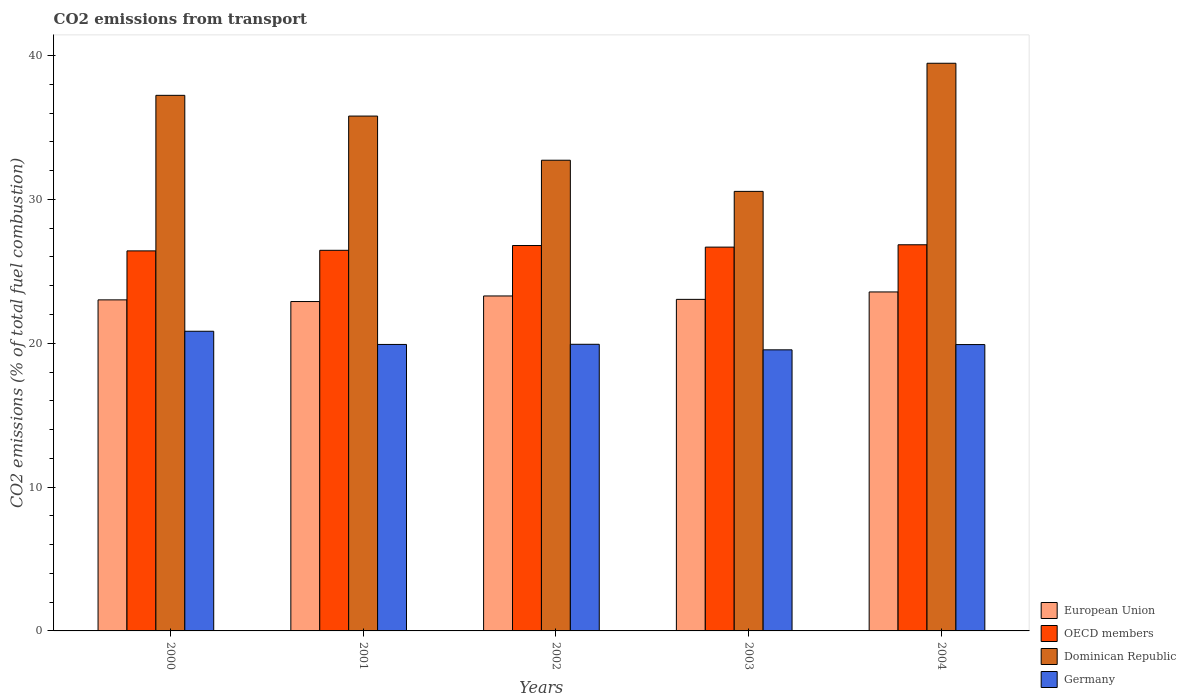How many different coloured bars are there?
Provide a succinct answer. 4. Are the number of bars on each tick of the X-axis equal?
Give a very brief answer. Yes. How many bars are there on the 1st tick from the left?
Your answer should be compact. 4. How many bars are there on the 4th tick from the right?
Keep it short and to the point. 4. What is the label of the 4th group of bars from the left?
Provide a short and direct response. 2003. In how many cases, is the number of bars for a given year not equal to the number of legend labels?
Give a very brief answer. 0. What is the total CO2 emitted in Germany in 2002?
Your answer should be very brief. 19.93. Across all years, what is the maximum total CO2 emitted in European Union?
Offer a very short reply. 23.57. Across all years, what is the minimum total CO2 emitted in European Union?
Keep it short and to the point. 22.9. What is the total total CO2 emitted in Germany in the graph?
Give a very brief answer. 100.13. What is the difference between the total CO2 emitted in Dominican Republic in 2002 and that in 2003?
Offer a terse response. 2.17. What is the difference between the total CO2 emitted in Dominican Republic in 2000 and the total CO2 emitted in OECD members in 2004?
Your answer should be very brief. 10.39. What is the average total CO2 emitted in OECD members per year?
Offer a very short reply. 26.64. In the year 2000, what is the difference between the total CO2 emitted in European Union and total CO2 emitted in OECD members?
Offer a terse response. -3.41. What is the ratio of the total CO2 emitted in Germany in 2003 to that in 2004?
Your answer should be compact. 0.98. Is the total CO2 emitted in European Union in 2001 less than that in 2003?
Make the answer very short. Yes. What is the difference between the highest and the second highest total CO2 emitted in Dominican Republic?
Provide a succinct answer. 2.23. What is the difference between the highest and the lowest total CO2 emitted in Dominican Republic?
Offer a very short reply. 8.91. In how many years, is the total CO2 emitted in Dominican Republic greater than the average total CO2 emitted in Dominican Republic taken over all years?
Offer a terse response. 3. Is it the case that in every year, the sum of the total CO2 emitted in Germany and total CO2 emitted in European Union is greater than the sum of total CO2 emitted in Dominican Republic and total CO2 emitted in OECD members?
Your answer should be compact. No. What does the 2nd bar from the left in 2003 represents?
Your answer should be compact. OECD members. Is it the case that in every year, the sum of the total CO2 emitted in European Union and total CO2 emitted in Germany is greater than the total CO2 emitted in OECD members?
Offer a very short reply. Yes. How many bars are there?
Give a very brief answer. 20. How many years are there in the graph?
Your answer should be very brief. 5. Are the values on the major ticks of Y-axis written in scientific E-notation?
Your answer should be very brief. No. Does the graph contain grids?
Offer a terse response. No. Where does the legend appear in the graph?
Offer a terse response. Bottom right. What is the title of the graph?
Give a very brief answer. CO2 emissions from transport. What is the label or title of the Y-axis?
Ensure brevity in your answer.  CO2 emissions (% of total fuel combustion). What is the CO2 emissions (% of total fuel combustion) of European Union in 2000?
Ensure brevity in your answer.  23.02. What is the CO2 emissions (% of total fuel combustion) in OECD members in 2000?
Give a very brief answer. 26.42. What is the CO2 emissions (% of total fuel combustion) of Dominican Republic in 2000?
Provide a succinct answer. 37.24. What is the CO2 emissions (% of total fuel combustion) of Germany in 2000?
Provide a succinct answer. 20.83. What is the CO2 emissions (% of total fuel combustion) of European Union in 2001?
Provide a short and direct response. 22.9. What is the CO2 emissions (% of total fuel combustion) of OECD members in 2001?
Provide a short and direct response. 26.46. What is the CO2 emissions (% of total fuel combustion) of Dominican Republic in 2001?
Your response must be concise. 35.8. What is the CO2 emissions (% of total fuel combustion) of Germany in 2001?
Provide a short and direct response. 19.92. What is the CO2 emissions (% of total fuel combustion) in European Union in 2002?
Offer a very short reply. 23.29. What is the CO2 emissions (% of total fuel combustion) in OECD members in 2002?
Offer a terse response. 26.79. What is the CO2 emissions (% of total fuel combustion) in Dominican Republic in 2002?
Offer a very short reply. 32.73. What is the CO2 emissions (% of total fuel combustion) in Germany in 2002?
Your answer should be very brief. 19.93. What is the CO2 emissions (% of total fuel combustion) of European Union in 2003?
Offer a terse response. 23.05. What is the CO2 emissions (% of total fuel combustion) of OECD members in 2003?
Your answer should be compact. 26.68. What is the CO2 emissions (% of total fuel combustion) of Dominican Republic in 2003?
Offer a terse response. 30.56. What is the CO2 emissions (% of total fuel combustion) in Germany in 2003?
Your response must be concise. 19.54. What is the CO2 emissions (% of total fuel combustion) of European Union in 2004?
Give a very brief answer. 23.57. What is the CO2 emissions (% of total fuel combustion) in OECD members in 2004?
Provide a short and direct response. 26.85. What is the CO2 emissions (% of total fuel combustion) of Dominican Republic in 2004?
Your answer should be compact. 39.47. What is the CO2 emissions (% of total fuel combustion) in Germany in 2004?
Ensure brevity in your answer.  19.91. Across all years, what is the maximum CO2 emissions (% of total fuel combustion) of European Union?
Your answer should be very brief. 23.57. Across all years, what is the maximum CO2 emissions (% of total fuel combustion) of OECD members?
Offer a very short reply. 26.85. Across all years, what is the maximum CO2 emissions (% of total fuel combustion) of Dominican Republic?
Your answer should be compact. 39.47. Across all years, what is the maximum CO2 emissions (% of total fuel combustion) of Germany?
Offer a very short reply. 20.83. Across all years, what is the minimum CO2 emissions (% of total fuel combustion) in European Union?
Give a very brief answer. 22.9. Across all years, what is the minimum CO2 emissions (% of total fuel combustion) of OECD members?
Offer a very short reply. 26.42. Across all years, what is the minimum CO2 emissions (% of total fuel combustion) of Dominican Republic?
Provide a succinct answer. 30.56. Across all years, what is the minimum CO2 emissions (% of total fuel combustion) in Germany?
Your response must be concise. 19.54. What is the total CO2 emissions (% of total fuel combustion) of European Union in the graph?
Ensure brevity in your answer.  115.82. What is the total CO2 emissions (% of total fuel combustion) of OECD members in the graph?
Offer a very short reply. 133.21. What is the total CO2 emissions (% of total fuel combustion) in Dominican Republic in the graph?
Make the answer very short. 175.78. What is the total CO2 emissions (% of total fuel combustion) in Germany in the graph?
Offer a very short reply. 100.13. What is the difference between the CO2 emissions (% of total fuel combustion) of European Union in 2000 and that in 2001?
Provide a succinct answer. 0.12. What is the difference between the CO2 emissions (% of total fuel combustion) of OECD members in 2000 and that in 2001?
Ensure brevity in your answer.  -0.04. What is the difference between the CO2 emissions (% of total fuel combustion) of Dominican Republic in 2000 and that in 2001?
Your answer should be compact. 1.44. What is the difference between the CO2 emissions (% of total fuel combustion) in Germany in 2000 and that in 2001?
Offer a very short reply. 0.92. What is the difference between the CO2 emissions (% of total fuel combustion) in European Union in 2000 and that in 2002?
Offer a terse response. -0.27. What is the difference between the CO2 emissions (% of total fuel combustion) in OECD members in 2000 and that in 2002?
Provide a short and direct response. -0.37. What is the difference between the CO2 emissions (% of total fuel combustion) of Dominican Republic in 2000 and that in 2002?
Make the answer very short. 4.51. What is the difference between the CO2 emissions (% of total fuel combustion) in Germany in 2000 and that in 2002?
Offer a terse response. 0.91. What is the difference between the CO2 emissions (% of total fuel combustion) in European Union in 2000 and that in 2003?
Provide a succinct answer. -0.04. What is the difference between the CO2 emissions (% of total fuel combustion) in OECD members in 2000 and that in 2003?
Offer a very short reply. -0.26. What is the difference between the CO2 emissions (% of total fuel combustion) of Dominican Republic in 2000 and that in 2003?
Ensure brevity in your answer.  6.68. What is the difference between the CO2 emissions (% of total fuel combustion) of Germany in 2000 and that in 2003?
Ensure brevity in your answer.  1.29. What is the difference between the CO2 emissions (% of total fuel combustion) of European Union in 2000 and that in 2004?
Ensure brevity in your answer.  -0.55. What is the difference between the CO2 emissions (% of total fuel combustion) of OECD members in 2000 and that in 2004?
Offer a terse response. -0.43. What is the difference between the CO2 emissions (% of total fuel combustion) of Dominican Republic in 2000 and that in 2004?
Your response must be concise. -2.23. What is the difference between the CO2 emissions (% of total fuel combustion) of Germany in 2000 and that in 2004?
Make the answer very short. 0.93. What is the difference between the CO2 emissions (% of total fuel combustion) of European Union in 2001 and that in 2002?
Make the answer very short. -0.39. What is the difference between the CO2 emissions (% of total fuel combustion) of OECD members in 2001 and that in 2002?
Offer a very short reply. -0.33. What is the difference between the CO2 emissions (% of total fuel combustion) of Dominican Republic in 2001 and that in 2002?
Give a very brief answer. 3.07. What is the difference between the CO2 emissions (% of total fuel combustion) of Germany in 2001 and that in 2002?
Provide a succinct answer. -0.01. What is the difference between the CO2 emissions (% of total fuel combustion) of European Union in 2001 and that in 2003?
Give a very brief answer. -0.15. What is the difference between the CO2 emissions (% of total fuel combustion) in OECD members in 2001 and that in 2003?
Offer a very short reply. -0.22. What is the difference between the CO2 emissions (% of total fuel combustion) in Dominican Republic in 2001 and that in 2003?
Provide a short and direct response. 5.24. What is the difference between the CO2 emissions (% of total fuel combustion) in Germany in 2001 and that in 2003?
Provide a short and direct response. 0.37. What is the difference between the CO2 emissions (% of total fuel combustion) of European Union in 2001 and that in 2004?
Keep it short and to the point. -0.67. What is the difference between the CO2 emissions (% of total fuel combustion) in OECD members in 2001 and that in 2004?
Provide a succinct answer. -0.39. What is the difference between the CO2 emissions (% of total fuel combustion) of Dominican Republic in 2001 and that in 2004?
Your answer should be very brief. -3.67. What is the difference between the CO2 emissions (% of total fuel combustion) in Germany in 2001 and that in 2004?
Offer a terse response. 0.01. What is the difference between the CO2 emissions (% of total fuel combustion) in European Union in 2002 and that in 2003?
Offer a terse response. 0.24. What is the difference between the CO2 emissions (% of total fuel combustion) in OECD members in 2002 and that in 2003?
Offer a terse response. 0.11. What is the difference between the CO2 emissions (% of total fuel combustion) of Dominican Republic in 2002 and that in 2003?
Offer a terse response. 2.17. What is the difference between the CO2 emissions (% of total fuel combustion) in Germany in 2002 and that in 2003?
Offer a very short reply. 0.39. What is the difference between the CO2 emissions (% of total fuel combustion) of European Union in 2002 and that in 2004?
Provide a short and direct response. -0.28. What is the difference between the CO2 emissions (% of total fuel combustion) in OECD members in 2002 and that in 2004?
Provide a short and direct response. -0.05. What is the difference between the CO2 emissions (% of total fuel combustion) in Dominican Republic in 2002 and that in 2004?
Provide a short and direct response. -6.74. What is the difference between the CO2 emissions (% of total fuel combustion) of Germany in 2002 and that in 2004?
Your answer should be very brief. 0.02. What is the difference between the CO2 emissions (% of total fuel combustion) of European Union in 2003 and that in 2004?
Your answer should be compact. -0.52. What is the difference between the CO2 emissions (% of total fuel combustion) of OECD members in 2003 and that in 2004?
Ensure brevity in your answer.  -0.16. What is the difference between the CO2 emissions (% of total fuel combustion) of Dominican Republic in 2003 and that in 2004?
Offer a terse response. -8.91. What is the difference between the CO2 emissions (% of total fuel combustion) of Germany in 2003 and that in 2004?
Your answer should be compact. -0.37. What is the difference between the CO2 emissions (% of total fuel combustion) in European Union in 2000 and the CO2 emissions (% of total fuel combustion) in OECD members in 2001?
Provide a short and direct response. -3.45. What is the difference between the CO2 emissions (% of total fuel combustion) of European Union in 2000 and the CO2 emissions (% of total fuel combustion) of Dominican Republic in 2001?
Give a very brief answer. -12.78. What is the difference between the CO2 emissions (% of total fuel combustion) in European Union in 2000 and the CO2 emissions (% of total fuel combustion) in Germany in 2001?
Keep it short and to the point. 3.1. What is the difference between the CO2 emissions (% of total fuel combustion) in OECD members in 2000 and the CO2 emissions (% of total fuel combustion) in Dominican Republic in 2001?
Offer a terse response. -9.37. What is the difference between the CO2 emissions (% of total fuel combustion) of OECD members in 2000 and the CO2 emissions (% of total fuel combustion) of Germany in 2001?
Give a very brief answer. 6.5. What is the difference between the CO2 emissions (% of total fuel combustion) of Dominican Republic in 2000 and the CO2 emissions (% of total fuel combustion) of Germany in 2001?
Your response must be concise. 17.32. What is the difference between the CO2 emissions (% of total fuel combustion) of European Union in 2000 and the CO2 emissions (% of total fuel combustion) of OECD members in 2002?
Make the answer very short. -3.78. What is the difference between the CO2 emissions (% of total fuel combustion) of European Union in 2000 and the CO2 emissions (% of total fuel combustion) of Dominican Republic in 2002?
Provide a succinct answer. -9.71. What is the difference between the CO2 emissions (% of total fuel combustion) of European Union in 2000 and the CO2 emissions (% of total fuel combustion) of Germany in 2002?
Make the answer very short. 3.09. What is the difference between the CO2 emissions (% of total fuel combustion) of OECD members in 2000 and the CO2 emissions (% of total fuel combustion) of Dominican Republic in 2002?
Offer a very short reply. -6.3. What is the difference between the CO2 emissions (% of total fuel combustion) of OECD members in 2000 and the CO2 emissions (% of total fuel combustion) of Germany in 2002?
Provide a short and direct response. 6.49. What is the difference between the CO2 emissions (% of total fuel combustion) in Dominican Republic in 2000 and the CO2 emissions (% of total fuel combustion) in Germany in 2002?
Offer a terse response. 17.31. What is the difference between the CO2 emissions (% of total fuel combustion) of European Union in 2000 and the CO2 emissions (% of total fuel combustion) of OECD members in 2003?
Provide a succinct answer. -3.67. What is the difference between the CO2 emissions (% of total fuel combustion) of European Union in 2000 and the CO2 emissions (% of total fuel combustion) of Dominican Republic in 2003?
Offer a terse response. -7.54. What is the difference between the CO2 emissions (% of total fuel combustion) of European Union in 2000 and the CO2 emissions (% of total fuel combustion) of Germany in 2003?
Offer a very short reply. 3.47. What is the difference between the CO2 emissions (% of total fuel combustion) in OECD members in 2000 and the CO2 emissions (% of total fuel combustion) in Dominican Republic in 2003?
Keep it short and to the point. -4.14. What is the difference between the CO2 emissions (% of total fuel combustion) in OECD members in 2000 and the CO2 emissions (% of total fuel combustion) in Germany in 2003?
Provide a short and direct response. 6.88. What is the difference between the CO2 emissions (% of total fuel combustion) in Dominican Republic in 2000 and the CO2 emissions (% of total fuel combustion) in Germany in 2003?
Ensure brevity in your answer.  17.69. What is the difference between the CO2 emissions (% of total fuel combustion) of European Union in 2000 and the CO2 emissions (% of total fuel combustion) of OECD members in 2004?
Make the answer very short. -3.83. What is the difference between the CO2 emissions (% of total fuel combustion) in European Union in 2000 and the CO2 emissions (% of total fuel combustion) in Dominican Republic in 2004?
Ensure brevity in your answer.  -16.45. What is the difference between the CO2 emissions (% of total fuel combustion) in European Union in 2000 and the CO2 emissions (% of total fuel combustion) in Germany in 2004?
Offer a very short reply. 3.11. What is the difference between the CO2 emissions (% of total fuel combustion) of OECD members in 2000 and the CO2 emissions (% of total fuel combustion) of Dominican Republic in 2004?
Ensure brevity in your answer.  -13.04. What is the difference between the CO2 emissions (% of total fuel combustion) of OECD members in 2000 and the CO2 emissions (% of total fuel combustion) of Germany in 2004?
Offer a very short reply. 6.51. What is the difference between the CO2 emissions (% of total fuel combustion) of Dominican Republic in 2000 and the CO2 emissions (% of total fuel combustion) of Germany in 2004?
Offer a terse response. 17.33. What is the difference between the CO2 emissions (% of total fuel combustion) in European Union in 2001 and the CO2 emissions (% of total fuel combustion) in OECD members in 2002?
Ensure brevity in your answer.  -3.89. What is the difference between the CO2 emissions (% of total fuel combustion) in European Union in 2001 and the CO2 emissions (% of total fuel combustion) in Dominican Republic in 2002?
Keep it short and to the point. -9.82. What is the difference between the CO2 emissions (% of total fuel combustion) in European Union in 2001 and the CO2 emissions (% of total fuel combustion) in Germany in 2002?
Ensure brevity in your answer.  2.97. What is the difference between the CO2 emissions (% of total fuel combustion) in OECD members in 2001 and the CO2 emissions (% of total fuel combustion) in Dominican Republic in 2002?
Ensure brevity in your answer.  -6.26. What is the difference between the CO2 emissions (% of total fuel combustion) in OECD members in 2001 and the CO2 emissions (% of total fuel combustion) in Germany in 2002?
Your answer should be very brief. 6.53. What is the difference between the CO2 emissions (% of total fuel combustion) of Dominican Republic in 2001 and the CO2 emissions (% of total fuel combustion) of Germany in 2002?
Give a very brief answer. 15.87. What is the difference between the CO2 emissions (% of total fuel combustion) of European Union in 2001 and the CO2 emissions (% of total fuel combustion) of OECD members in 2003?
Provide a short and direct response. -3.78. What is the difference between the CO2 emissions (% of total fuel combustion) of European Union in 2001 and the CO2 emissions (% of total fuel combustion) of Dominican Republic in 2003?
Your answer should be compact. -7.66. What is the difference between the CO2 emissions (% of total fuel combustion) of European Union in 2001 and the CO2 emissions (% of total fuel combustion) of Germany in 2003?
Make the answer very short. 3.36. What is the difference between the CO2 emissions (% of total fuel combustion) of OECD members in 2001 and the CO2 emissions (% of total fuel combustion) of Dominican Republic in 2003?
Offer a very short reply. -4.1. What is the difference between the CO2 emissions (% of total fuel combustion) in OECD members in 2001 and the CO2 emissions (% of total fuel combustion) in Germany in 2003?
Make the answer very short. 6.92. What is the difference between the CO2 emissions (% of total fuel combustion) in Dominican Republic in 2001 and the CO2 emissions (% of total fuel combustion) in Germany in 2003?
Your answer should be very brief. 16.25. What is the difference between the CO2 emissions (% of total fuel combustion) in European Union in 2001 and the CO2 emissions (% of total fuel combustion) in OECD members in 2004?
Offer a very short reply. -3.95. What is the difference between the CO2 emissions (% of total fuel combustion) in European Union in 2001 and the CO2 emissions (% of total fuel combustion) in Dominican Republic in 2004?
Offer a very short reply. -16.57. What is the difference between the CO2 emissions (% of total fuel combustion) of European Union in 2001 and the CO2 emissions (% of total fuel combustion) of Germany in 2004?
Your response must be concise. 2.99. What is the difference between the CO2 emissions (% of total fuel combustion) of OECD members in 2001 and the CO2 emissions (% of total fuel combustion) of Dominican Republic in 2004?
Offer a terse response. -13. What is the difference between the CO2 emissions (% of total fuel combustion) of OECD members in 2001 and the CO2 emissions (% of total fuel combustion) of Germany in 2004?
Ensure brevity in your answer.  6.55. What is the difference between the CO2 emissions (% of total fuel combustion) in Dominican Republic in 2001 and the CO2 emissions (% of total fuel combustion) in Germany in 2004?
Offer a terse response. 15.89. What is the difference between the CO2 emissions (% of total fuel combustion) of European Union in 2002 and the CO2 emissions (% of total fuel combustion) of OECD members in 2003?
Make the answer very short. -3.4. What is the difference between the CO2 emissions (% of total fuel combustion) in European Union in 2002 and the CO2 emissions (% of total fuel combustion) in Dominican Republic in 2003?
Your answer should be compact. -7.27. What is the difference between the CO2 emissions (% of total fuel combustion) in European Union in 2002 and the CO2 emissions (% of total fuel combustion) in Germany in 2003?
Your answer should be compact. 3.75. What is the difference between the CO2 emissions (% of total fuel combustion) of OECD members in 2002 and the CO2 emissions (% of total fuel combustion) of Dominican Republic in 2003?
Your response must be concise. -3.76. What is the difference between the CO2 emissions (% of total fuel combustion) in OECD members in 2002 and the CO2 emissions (% of total fuel combustion) in Germany in 2003?
Your answer should be very brief. 7.25. What is the difference between the CO2 emissions (% of total fuel combustion) in Dominican Republic in 2002 and the CO2 emissions (% of total fuel combustion) in Germany in 2003?
Your answer should be very brief. 13.18. What is the difference between the CO2 emissions (% of total fuel combustion) in European Union in 2002 and the CO2 emissions (% of total fuel combustion) in OECD members in 2004?
Your answer should be very brief. -3.56. What is the difference between the CO2 emissions (% of total fuel combustion) in European Union in 2002 and the CO2 emissions (% of total fuel combustion) in Dominican Republic in 2004?
Offer a very short reply. -16.18. What is the difference between the CO2 emissions (% of total fuel combustion) in European Union in 2002 and the CO2 emissions (% of total fuel combustion) in Germany in 2004?
Your answer should be very brief. 3.38. What is the difference between the CO2 emissions (% of total fuel combustion) of OECD members in 2002 and the CO2 emissions (% of total fuel combustion) of Dominican Republic in 2004?
Your response must be concise. -12.67. What is the difference between the CO2 emissions (% of total fuel combustion) in OECD members in 2002 and the CO2 emissions (% of total fuel combustion) in Germany in 2004?
Your answer should be compact. 6.89. What is the difference between the CO2 emissions (% of total fuel combustion) of Dominican Republic in 2002 and the CO2 emissions (% of total fuel combustion) of Germany in 2004?
Provide a succinct answer. 12.82. What is the difference between the CO2 emissions (% of total fuel combustion) in European Union in 2003 and the CO2 emissions (% of total fuel combustion) in OECD members in 2004?
Offer a very short reply. -3.8. What is the difference between the CO2 emissions (% of total fuel combustion) of European Union in 2003 and the CO2 emissions (% of total fuel combustion) of Dominican Republic in 2004?
Offer a terse response. -16.42. What is the difference between the CO2 emissions (% of total fuel combustion) of European Union in 2003 and the CO2 emissions (% of total fuel combustion) of Germany in 2004?
Keep it short and to the point. 3.14. What is the difference between the CO2 emissions (% of total fuel combustion) in OECD members in 2003 and the CO2 emissions (% of total fuel combustion) in Dominican Republic in 2004?
Give a very brief answer. -12.78. What is the difference between the CO2 emissions (% of total fuel combustion) of OECD members in 2003 and the CO2 emissions (% of total fuel combustion) of Germany in 2004?
Offer a terse response. 6.78. What is the difference between the CO2 emissions (% of total fuel combustion) of Dominican Republic in 2003 and the CO2 emissions (% of total fuel combustion) of Germany in 2004?
Make the answer very short. 10.65. What is the average CO2 emissions (% of total fuel combustion) in European Union per year?
Provide a succinct answer. 23.16. What is the average CO2 emissions (% of total fuel combustion) in OECD members per year?
Give a very brief answer. 26.64. What is the average CO2 emissions (% of total fuel combustion) of Dominican Republic per year?
Provide a succinct answer. 35.16. What is the average CO2 emissions (% of total fuel combustion) in Germany per year?
Your answer should be very brief. 20.03. In the year 2000, what is the difference between the CO2 emissions (% of total fuel combustion) in European Union and CO2 emissions (% of total fuel combustion) in OECD members?
Ensure brevity in your answer.  -3.41. In the year 2000, what is the difference between the CO2 emissions (% of total fuel combustion) of European Union and CO2 emissions (% of total fuel combustion) of Dominican Republic?
Your answer should be compact. -14.22. In the year 2000, what is the difference between the CO2 emissions (% of total fuel combustion) of European Union and CO2 emissions (% of total fuel combustion) of Germany?
Your answer should be compact. 2.18. In the year 2000, what is the difference between the CO2 emissions (% of total fuel combustion) in OECD members and CO2 emissions (% of total fuel combustion) in Dominican Republic?
Provide a short and direct response. -10.81. In the year 2000, what is the difference between the CO2 emissions (% of total fuel combustion) of OECD members and CO2 emissions (% of total fuel combustion) of Germany?
Provide a short and direct response. 5.59. In the year 2000, what is the difference between the CO2 emissions (% of total fuel combustion) in Dominican Republic and CO2 emissions (% of total fuel combustion) in Germany?
Your answer should be compact. 16.4. In the year 2001, what is the difference between the CO2 emissions (% of total fuel combustion) of European Union and CO2 emissions (% of total fuel combustion) of OECD members?
Offer a terse response. -3.56. In the year 2001, what is the difference between the CO2 emissions (% of total fuel combustion) in European Union and CO2 emissions (% of total fuel combustion) in Dominican Republic?
Give a very brief answer. -12.9. In the year 2001, what is the difference between the CO2 emissions (% of total fuel combustion) in European Union and CO2 emissions (% of total fuel combustion) in Germany?
Your answer should be compact. 2.98. In the year 2001, what is the difference between the CO2 emissions (% of total fuel combustion) of OECD members and CO2 emissions (% of total fuel combustion) of Dominican Republic?
Provide a short and direct response. -9.33. In the year 2001, what is the difference between the CO2 emissions (% of total fuel combustion) in OECD members and CO2 emissions (% of total fuel combustion) in Germany?
Offer a terse response. 6.54. In the year 2001, what is the difference between the CO2 emissions (% of total fuel combustion) in Dominican Republic and CO2 emissions (% of total fuel combustion) in Germany?
Give a very brief answer. 15.88. In the year 2002, what is the difference between the CO2 emissions (% of total fuel combustion) of European Union and CO2 emissions (% of total fuel combustion) of OECD members?
Offer a terse response. -3.51. In the year 2002, what is the difference between the CO2 emissions (% of total fuel combustion) of European Union and CO2 emissions (% of total fuel combustion) of Dominican Republic?
Offer a terse response. -9.44. In the year 2002, what is the difference between the CO2 emissions (% of total fuel combustion) of European Union and CO2 emissions (% of total fuel combustion) of Germany?
Offer a terse response. 3.36. In the year 2002, what is the difference between the CO2 emissions (% of total fuel combustion) in OECD members and CO2 emissions (% of total fuel combustion) in Dominican Republic?
Ensure brevity in your answer.  -5.93. In the year 2002, what is the difference between the CO2 emissions (% of total fuel combustion) of OECD members and CO2 emissions (% of total fuel combustion) of Germany?
Your answer should be compact. 6.87. In the year 2002, what is the difference between the CO2 emissions (% of total fuel combustion) in Dominican Republic and CO2 emissions (% of total fuel combustion) in Germany?
Provide a succinct answer. 12.8. In the year 2003, what is the difference between the CO2 emissions (% of total fuel combustion) in European Union and CO2 emissions (% of total fuel combustion) in OECD members?
Offer a terse response. -3.63. In the year 2003, what is the difference between the CO2 emissions (% of total fuel combustion) in European Union and CO2 emissions (% of total fuel combustion) in Dominican Republic?
Your answer should be compact. -7.51. In the year 2003, what is the difference between the CO2 emissions (% of total fuel combustion) of European Union and CO2 emissions (% of total fuel combustion) of Germany?
Offer a terse response. 3.51. In the year 2003, what is the difference between the CO2 emissions (% of total fuel combustion) of OECD members and CO2 emissions (% of total fuel combustion) of Dominican Republic?
Keep it short and to the point. -3.88. In the year 2003, what is the difference between the CO2 emissions (% of total fuel combustion) in OECD members and CO2 emissions (% of total fuel combustion) in Germany?
Keep it short and to the point. 7.14. In the year 2003, what is the difference between the CO2 emissions (% of total fuel combustion) in Dominican Republic and CO2 emissions (% of total fuel combustion) in Germany?
Ensure brevity in your answer.  11.02. In the year 2004, what is the difference between the CO2 emissions (% of total fuel combustion) in European Union and CO2 emissions (% of total fuel combustion) in OECD members?
Keep it short and to the point. -3.28. In the year 2004, what is the difference between the CO2 emissions (% of total fuel combustion) in European Union and CO2 emissions (% of total fuel combustion) in Dominican Republic?
Provide a succinct answer. -15.9. In the year 2004, what is the difference between the CO2 emissions (% of total fuel combustion) of European Union and CO2 emissions (% of total fuel combustion) of Germany?
Offer a terse response. 3.66. In the year 2004, what is the difference between the CO2 emissions (% of total fuel combustion) of OECD members and CO2 emissions (% of total fuel combustion) of Dominican Republic?
Your answer should be compact. -12.62. In the year 2004, what is the difference between the CO2 emissions (% of total fuel combustion) of OECD members and CO2 emissions (% of total fuel combustion) of Germany?
Your response must be concise. 6.94. In the year 2004, what is the difference between the CO2 emissions (% of total fuel combustion) in Dominican Republic and CO2 emissions (% of total fuel combustion) in Germany?
Make the answer very short. 19.56. What is the ratio of the CO2 emissions (% of total fuel combustion) of Dominican Republic in 2000 to that in 2001?
Provide a short and direct response. 1.04. What is the ratio of the CO2 emissions (% of total fuel combustion) in Germany in 2000 to that in 2001?
Make the answer very short. 1.05. What is the ratio of the CO2 emissions (% of total fuel combustion) in European Union in 2000 to that in 2002?
Ensure brevity in your answer.  0.99. What is the ratio of the CO2 emissions (% of total fuel combustion) in OECD members in 2000 to that in 2002?
Keep it short and to the point. 0.99. What is the ratio of the CO2 emissions (% of total fuel combustion) of Dominican Republic in 2000 to that in 2002?
Your response must be concise. 1.14. What is the ratio of the CO2 emissions (% of total fuel combustion) in Germany in 2000 to that in 2002?
Ensure brevity in your answer.  1.05. What is the ratio of the CO2 emissions (% of total fuel combustion) of OECD members in 2000 to that in 2003?
Your response must be concise. 0.99. What is the ratio of the CO2 emissions (% of total fuel combustion) in Dominican Republic in 2000 to that in 2003?
Make the answer very short. 1.22. What is the ratio of the CO2 emissions (% of total fuel combustion) in Germany in 2000 to that in 2003?
Provide a short and direct response. 1.07. What is the ratio of the CO2 emissions (% of total fuel combustion) of European Union in 2000 to that in 2004?
Offer a terse response. 0.98. What is the ratio of the CO2 emissions (% of total fuel combustion) of OECD members in 2000 to that in 2004?
Your answer should be compact. 0.98. What is the ratio of the CO2 emissions (% of total fuel combustion) in Dominican Republic in 2000 to that in 2004?
Ensure brevity in your answer.  0.94. What is the ratio of the CO2 emissions (% of total fuel combustion) in Germany in 2000 to that in 2004?
Ensure brevity in your answer.  1.05. What is the ratio of the CO2 emissions (% of total fuel combustion) in European Union in 2001 to that in 2002?
Ensure brevity in your answer.  0.98. What is the ratio of the CO2 emissions (% of total fuel combustion) of OECD members in 2001 to that in 2002?
Offer a very short reply. 0.99. What is the ratio of the CO2 emissions (% of total fuel combustion) in Dominican Republic in 2001 to that in 2002?
Offer a terse response. 1.09. What is the ratio of the CO2 emissions (% of total fuel combustion) in Dominican Republic in 2001 to that in 2003?
Make the answer very short. 1.17. What is the ratio of the CO2 emissions (% of total fuel combustion) in Germany in 2001 to that in 2003?
Keep it short and to the point. 1.02. What is the ratio of the CO2 emissions (% of total fuel combustion) of European Union in 2001 to that in 2004?
Offer a very short reply. 0.97. What is the ratio of the CO2 emissions (% of total fuel combustion) of OECD members in 2001 to that in 2004?
Make the answer very short. 0.99. What is the ratio of the CO2 emissions (% of total fuel combustion) of Dominican Republic in 2001 to that in 2004?
Keep it short and to the point. 0.91. What is the ratio of the CO2 emissions (% of total fuel combustion) of Germany in 2001 to that in 2004?
Make the answer very short. 1. What is the ratio of the CO2 emissions (% of total fuel combustion) of European Union in 2002 to that in 2003?
Offer a very short reply. 1.01. What is the ratio of the CO2 emissions (% of total fuel combustion) of Dominican Republic in 2002 to that in 2003?
Your response must be concise. 1.07. What is the ratio of the CO2 emissions (% of total fuel combustion) of Germany in 2002 to that in 2003?
Offer a terse response. 1.02. What is the ratio of the CO2 emissions (% of total fuel combustion) in Dominican Republic in 2002 to that in 2004?
Give a very brief answer. 0.83. What is the ratio of the CO2 emissions (% of total fuel combustion) in Germany in 2002 to that in 2004?
Keep it short and to the point. 1. What is the ratio of the CO2 emissions (% of total fuel combustion) in European Union in 2003 to that in 2004?
Your answer should be very brief. 0.98. What is the ratio of the CO2 emissions (% of total fuel combustion) in OECD members in 2003 to that in 2004?
Keep it short and to the point. 0.99. What is the ratio of the CO2 emissions (% of total fuel combustion) of Dominican Republic in 2003 to that in 2004?
Keep it short and to the point. 0.77. What is the ratio of the CO2 emissions (% of total fuel combustion) of Germany in 2003 to that in 2004?
Offer a terse response. 0.98. What is the difference between the highest and the second highest CO2 emissions (% of total fuel combustion) in European Union?
Make the answer very short. 0.28. What is the difference between the highest and the second highest CO2 emissions (% of total fuel combustion) of OECD members?
Your answer should be very brief. 0.05. What is the difference between the highest and the second highest CO2 emissions (% of total fuel combustion) of Dominican Republic?
Provide a short and direct response. 2.23. What is the difference between the highest and the second highest CO2 emissions (% of total fuel combustion) in Germany?
Your response must be concise. 0.91. What is the difference between the highest and the lowest CO2 emissions (% of total fuel combustion) of European Union?
Give a very brief answer. 0.67. What is the difference between the highest and the lowest CO2 emissions (% of total fuel combustion) of OECD members?
Provide a succinct answer. 0.43. What is the difference between the highest and the lowest CO2 emissions (% of total fuel combustion) of Dominican Republic?
Offer a very short reply. 8.91. What is the difference between the highest and the lowest CO2 emissions (% of total fuel combustion) of Germany?
Make the answer very short. 1.29. 